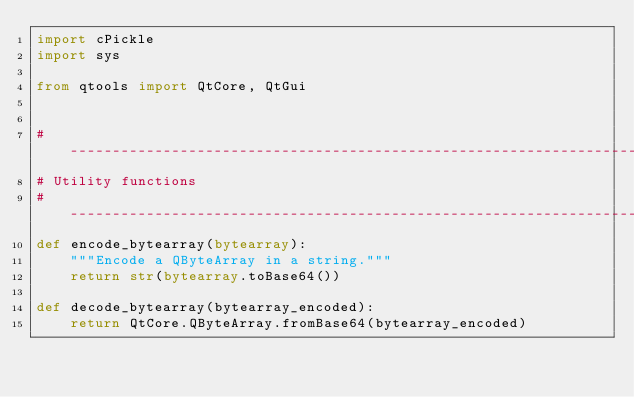Convert code to text. <code><loc_0><loc_0><loc_500><loc_500><_Python_>import cPickle
import sys

from qtools import QtCore, QtGui


# -----------------------------------------------------------------------------
# Utility functions
# -----------------------------------------------------------------------------
def encode_bytearray(bytearray):
    """Encode a QByteArray in a string."""
    return str(bytearray.toBase64())

def decode_bytearray(bytearray_encoded):
    return QtCore.QByteArray.fromBase64(bytearray_encoded)

</code> 